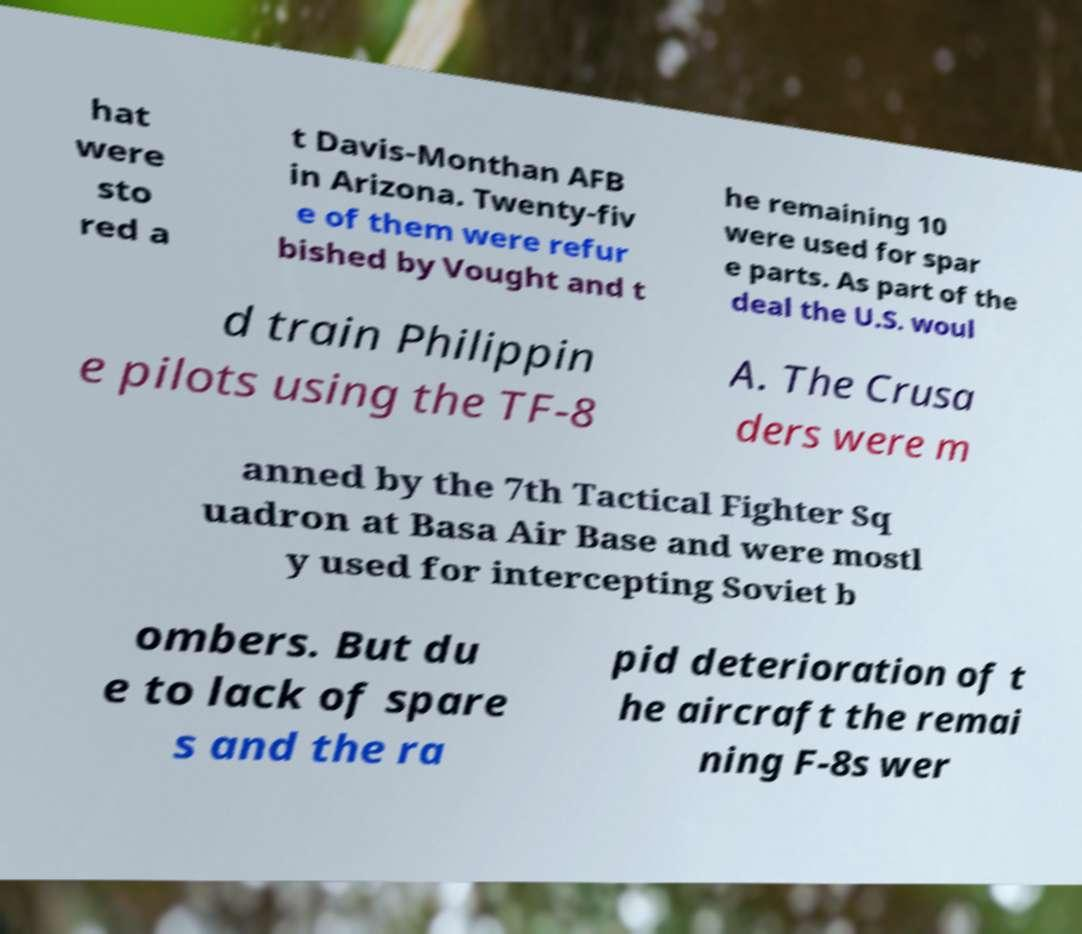For documentation purposes, I need the text within this image transcribed. Could you provide that? hat were sto red a t Davis-Monthan AFB in Arizona. Twenty-fiv e of them were refur bished by Vought and t he remaining 10 were used for spar e parts. As part of the deal the U.S. woul d train Philippin e pilots using the TF-8 A. The Crusa ders were m anned by the 7th Tactical Fighter Sq uadron at Basa Air Base and were mostl y used for intercepting Soviet b ombers. But du e to lack of spare s and the ra pid deterioration of t he aircraft the remai ning F-8s wer 